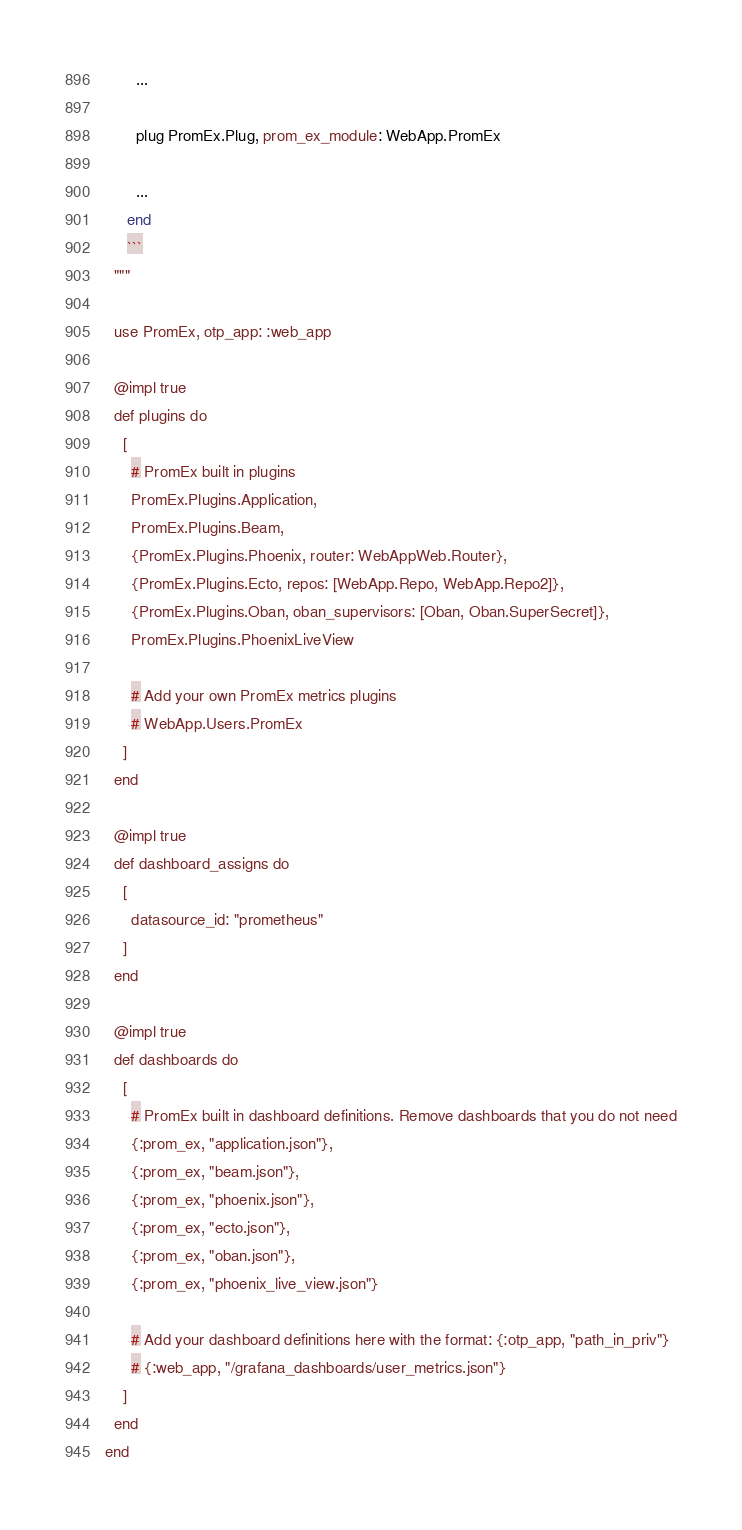Convert code to text. <code><loc_0><loc_0><loc_500><loc_500><_Elixir_>
       ...

       plug PromEx.Plug, prom_ex_module: WebApp.PromEx

       ...
     end
     ```
  """

  use PromEx, otp_app: :web_app

  @impl true
  def plugins do
    [
      # PromEx built in plugins
      PromEx.Plugins.Application,
      PromEx.Plugins.Beam,
      {PromEx.Plugins.Phoenix, router: WebAppWeb.Router},
      {PromEx.Plugins.Ecto, repos: [WebApp.Repo, WebApp.Repo2]},
      {PromEx.Plugins.Oban, oban_supervisors: [Oban, Oban.SuperSecret]},
      PromEx.Plugins.PhoenixLiveView

      # Add your own PromEx metrics plugins
      # WebApp.Users.PromEx
    ]
  end

  @impl true
  def dashboard_assigns do
    [
      datasource_id: "prometheus"
    ]
  end

  @impl true
  def dashboards do
    [
      # PromEx built in dashboard definitions. Remove dashboards that you do not need
      {:prom_ex, "application.json"},
      {:prom_ex, "beam.json"},
      {:prom_ex, "phoenix.json"},
      {:prom_ex, "ecto.json"},
      {:prom_ex, "oban.json"},
      {:prom_ex, "phoenix_live_view.json"}

      # Add your dashboard definitions here with the format: {:otp_app, "path_in_priv"}
      # {:web_app, "/grafana_dashboards/user_metrics.json"}
    ]
  end
end
</code> 